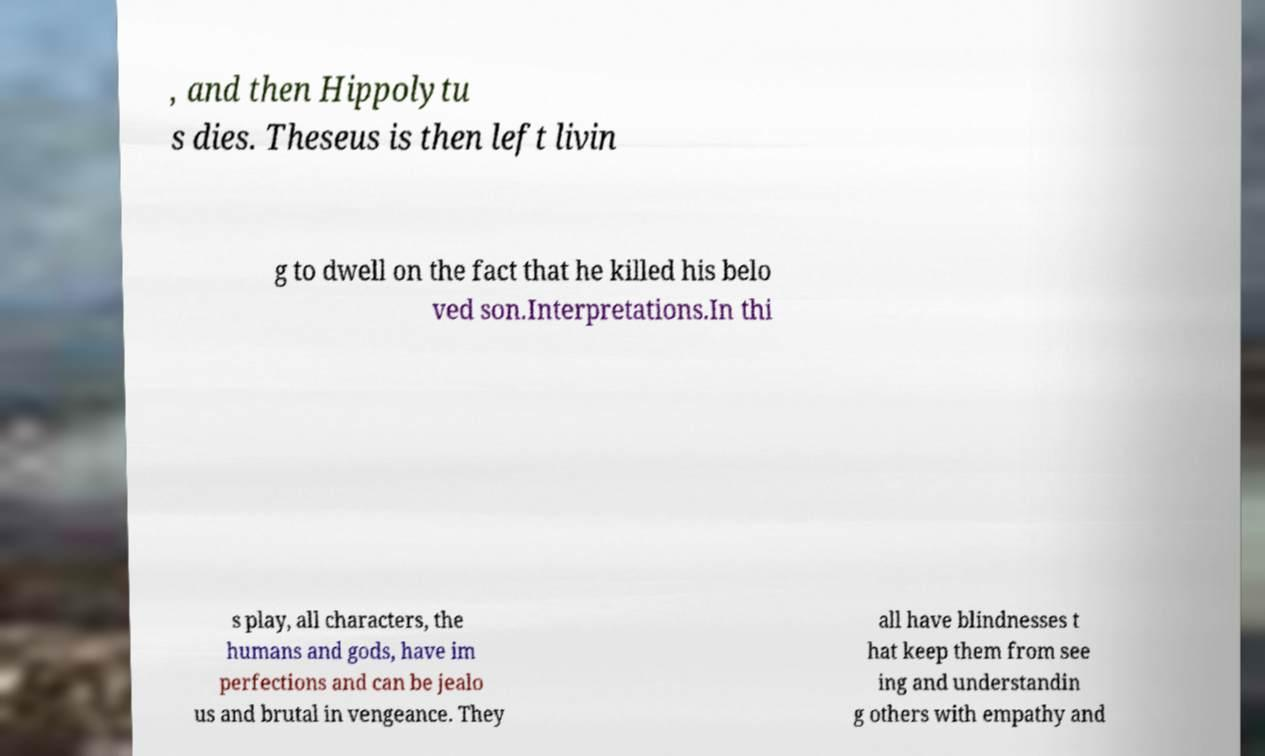Please identify and transcribe the text found in this image. , and then Hippolytu s dies. Theseus is then left livin g to dwell on the fact that he killed his belo ved son.Interpretations.In thi s play, all characters, the humans and gods, have im perfections and can be jealo us and brutal in vengeance. They all have blindnesses t hat keep them from see ing and understandin g others with empathy and 